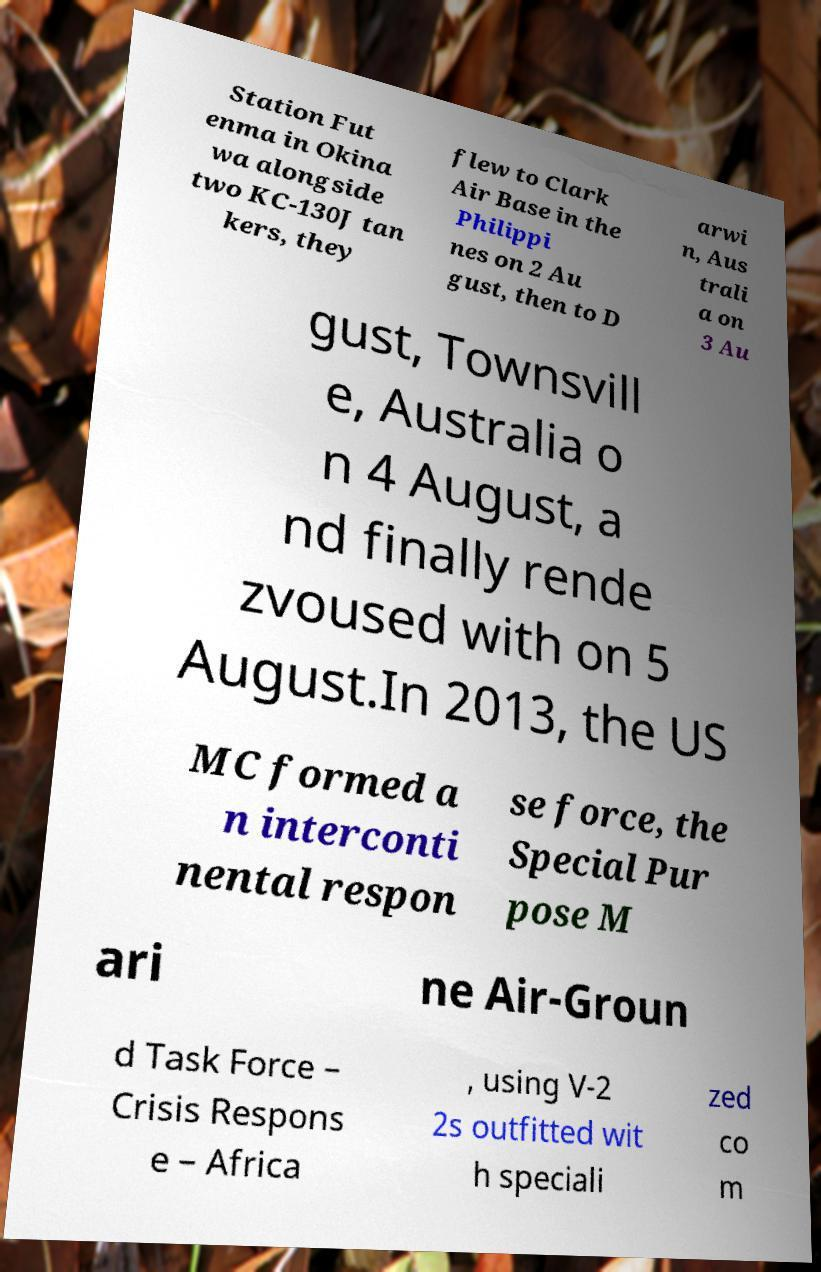Could you assist in decoding the text presented in this image and type it out clearly? Station Fut enma in Okina wa alongside two KC-130J tan kers, they flew to Clark Air Base in the Philippi nes on 2 Au gust, then to D arwi n, Aus trali a on 3 Au gust, Townsvill e, Australia o n 4 August, a nd finally rende zvoused with on 5 August.In 2013, the US MC formed a n interconti nental respon se force, the Special Pur pose M ari ne Air-Groun d Task Force – Crisis Respons e – Africa , using V-2 2s outfitted wit h speciali zed co m 